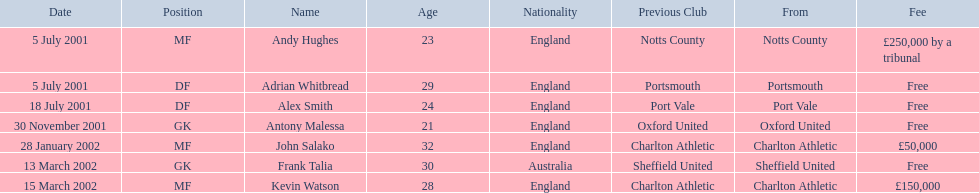Which players in the 2001-02 reading f.c. season played the mf position? Andy Hughes, John Salako, Kevin Watson. Of these players, which ones transferred in 2002? John Salako, Kevin Watson. Of these players, who had the highest transfer fee? Kevin Watson. What was this player's transfer fee? £150,000. 